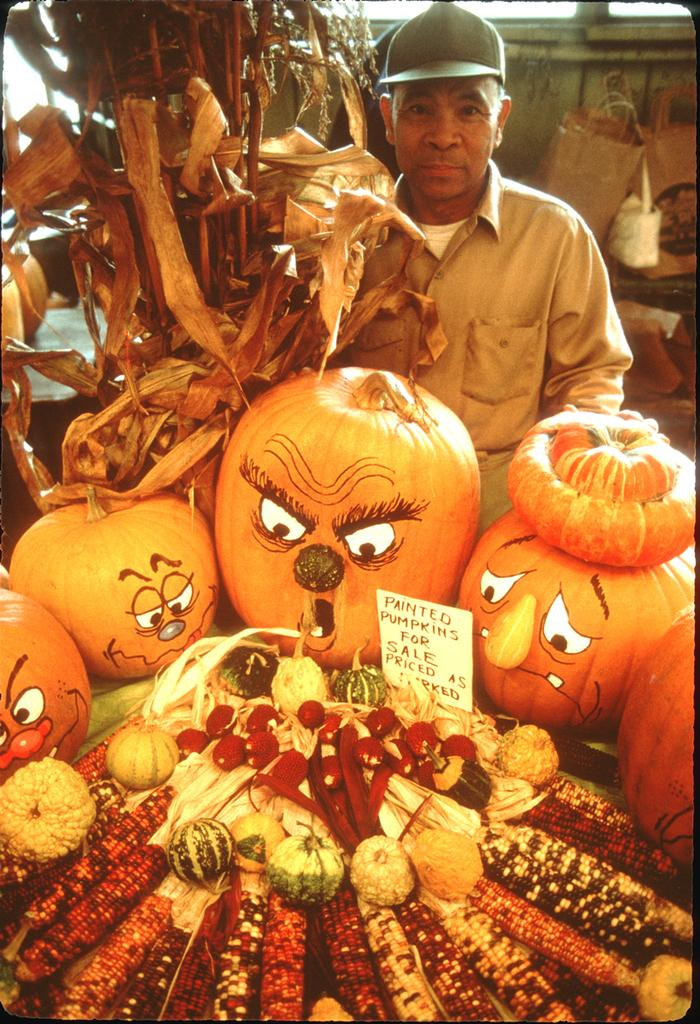What types of food items can be seen in the image? There are fruits and vegetables in the image. Can you describe the person in the image? There is a person in the image, but no specific details about their appearance or actions are provided. What can be seen in the background of the image? There are objects visible in the background of the image, but no specific details about them are provided. What type of credit card is the person using to purchase the fruits and vegetables in the image? There is no credit card or purchase activity depicted in the image. 